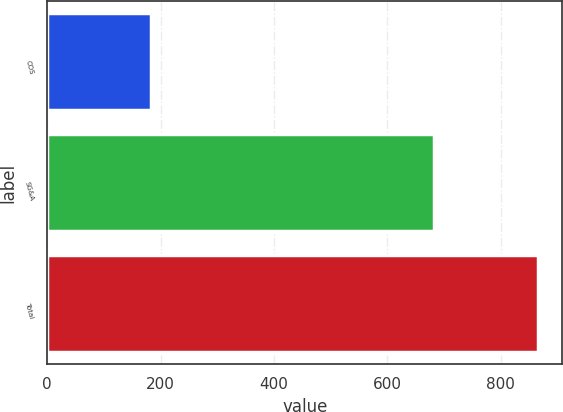Convert chart to OTSL. <chart><loc_0><loc_0><loc_500><loc_500><bar_chart><fcel>COS<fcel>SG&A<fcel>Total<nl><fcel>183<fcel>682<fcel>865<nl></chart> 